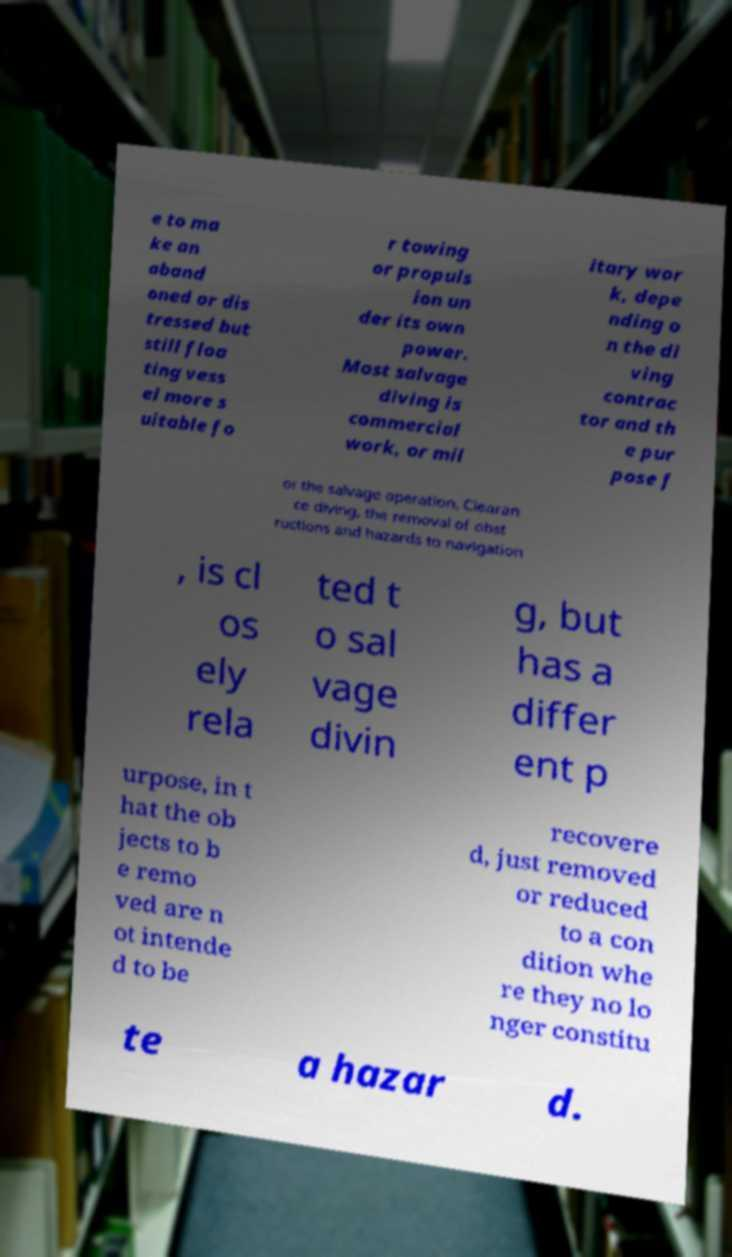Please read and relay the text visible in this image. What does it say? e to ma ke an aband oned or dis tressed but still floa ting vess el more s uitable fo r towing or propuls ion un der its own power. Most salvage diving is commercial work, or mil itary wor k, depe nding o n the di ving contrac tor and th e pur pose f or the salvage operation, Clearan ce diving, the removal of obst ructions and hazards to navigation , is cl os ely rela ted t o sal vage divin g, but has a differ ent p urpose, in t hat the ob jects to b e remo ved are n ot intende d to be recovere d, just removed or reduced to a con dition whe re they no lo nger constitu te a hazar d. 